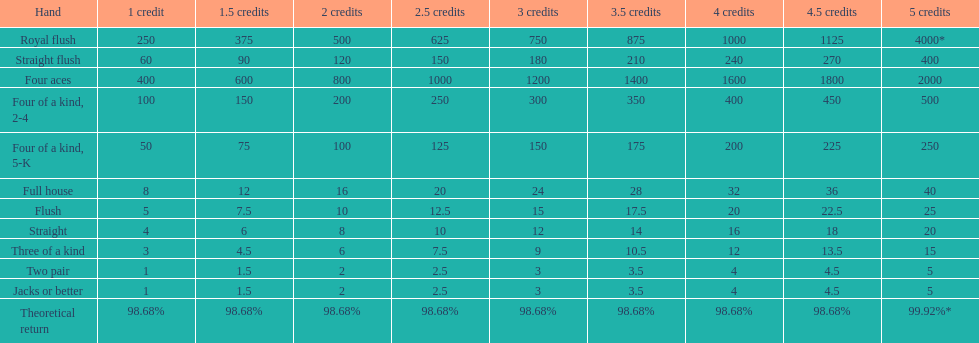After winning on four credits with a full house, what is your payout? 32. 